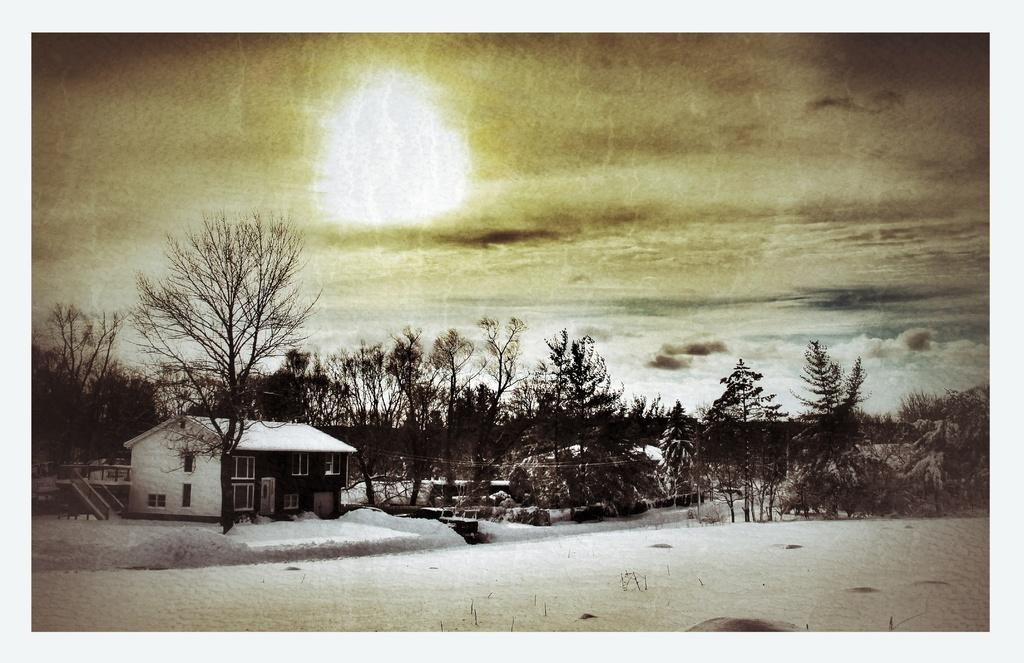What is the main subject of the image? There is a photo in the image. What can be seen in the photo? There is a house and trees in the photo. What is visible at the top of the photo? The sky is visible at the top of the photo. What type of wax is being used to coat the house in the photo? There is no mention of wax or any coating on the house in the image. The house appears to be a regular house with no special coating. 